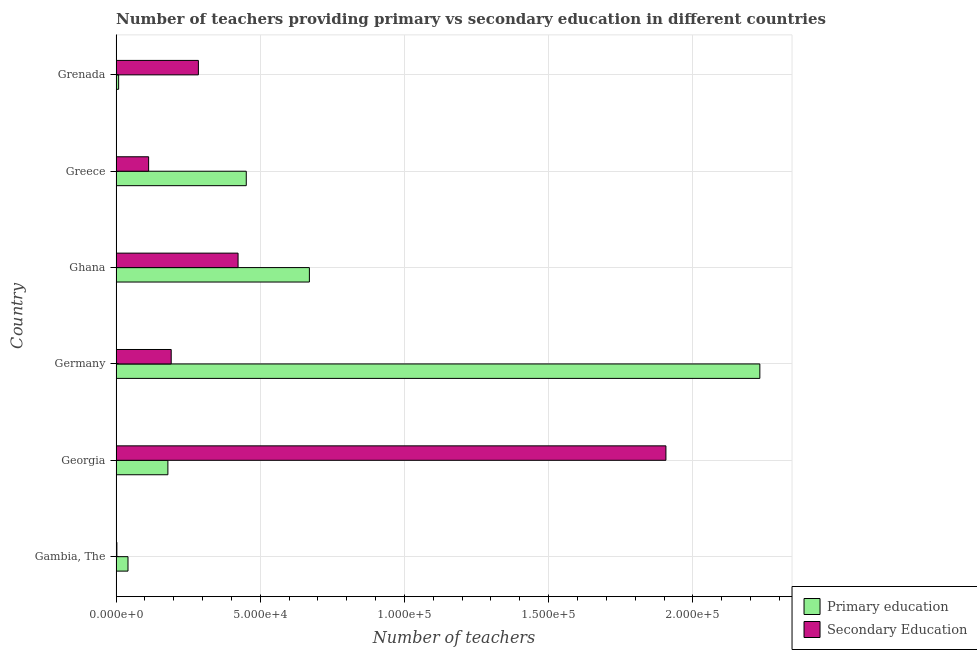How many groups of bars are there?
Your answer should be very brief. 6. Are the number of bars on each tick of the Y-axis equal?
Make the answer very short. Yes. How many bars are there on the 1st tick from the top?
Offer a terse response. 2. How many bars are there on the 5th tick from the bottom?
Keep it short and to the point. 2. What is the number of primary teachers in Greece?
Offer a terse response. 4.51e+04. Across all countries, what is the maximum number of secondary teachers?
Offer a very short reply. 1.91e+05. Across all countries, what is the minimum number of primary teachers?
Give a very brief answer. 869. In which country was the number of primary teachers minimum?
Keep it short and to the point. Grenada. What is the total number of secondary teachers in the graph?
Provide a succinct answer. 2.92e+05. What is the difference between the number of primary teachers in Georgia and that in Grenada?
Make the answer very short. 1.71e+04. What is the difference between the number of primary teachers in Ghana and the number of secondary teachers in Gambia, The?
Your answer should be very brief. 6.68e+04. What is the average number of primary teachers per country?
Ensure brevity in your answer.  5.97e+04. What is the difference between the number of primary teachers and number of secondary teachers in Germany?
Offer a very short reply. 2.04e+05. What is the ratio of the number of primary teachers in Ghana to that in Grenada?
Provide a short and direct response. 77.12. What is the difference between the highest and the second highest number of secondary teachers?
Offer a terse response. 1.48e+05. What is the difference between the highest and the lowest number of secondary teachers?
Your response must be concise. 1.90e+05. In how many countries, is the number of secondary teachers greater than the average number of secondary teachers taken over all countries?
Your answer should be compact. 1. What does the 1st bar from the top in Georgia represents?
Ensure brevity in your answer.  Secondary Education. What does the 2nd bar from the bottom in Grenada represents?
Your answer should be compact. Secondary Education. Are all the bars in the graph horizontal?
Your answer should be compact. Yes. What is the difference between two consecutive major ticks on the X-axis?
Provide a succinct answer. 5.00e+04. Are the values on the major ticks of X-axis written in scientific E-notation?
Keep it short and to the point. Yes. Does the graph contain grids?
Give a very brief answer. Yes. Where does the legend appear in the graph?
Your response must be concise. Bottom right. What is the title of the graph?
Offer a very short reply. Number of teachers providing primary vs secondary education in different countries. What is the label or title of the X-axis?
Keep it short and to the point. Number of teachers. What is the Number of teachers of Primary education in Gambia, The?
Ensure brevity in your answer.  4118. What is the Number of teachers in Secondary Education in Gambia, The?
Offer a terse response. 260. What is the Number of teachers of Primary education in Georgia?
Your answer should be very brief. 1.80e+04. What is the Number of teachers of Secondary Education in Georgia?
Ensure brevity in your answer.  1.91e+05. What is the Number of teachers of Primary education in Germany?
Your response must be concise. 2.23e+05. What is the Number of teachers in Secondary Education in Germany?
Your answer should be compact. 1.91e+04. What is the Number of teachers in Primary education in Ghana?
Your answer should be compact. 6.70e+04. What is the Number of teachers in Secondary Education in Ghana?
Your answer should be very brief. 4.23e+04. What is the Number of teachers in Primary education in Greece?
Your answer should be very brief. 4.51e+04. What is the Number of teachers in Secondary Education in Greece?
Offer a very short reply. 1.13e+04. What is the Number of teachers in Primary education in Grenada?
Provide a short and direct response. 869. What is the Number of teachers in Secondary Education in Grenada?
Offer a terse response. 2.85e+04. Across all countries, what is the maximum Number of teachers in Primary education?
Keep it short and to the point. 2.23e+05. Across all countries, what is the maximum Number of teachers of Secondary Education?
Your answer should be very brief. 1.91e+05. Across all countries, what is the minimum Number of teachers of Primary education?
Keep it short and to the point. 869. Across all countries, what is the minimum Number of teachers in Secondary Education?
Your response must be concise. 260. What is the total Number of teachers in Primary education in the graph?
Ensure brevity in your answer.  3.58e+05. What is the total Number of teachers in Secondary Education in the graph?
Provide a short and direct response. 2.92e+05. What is the difference between the Number of teachers of Primary education in Gambia, The and that in Georgia?
Your response must be concise. -1.38e+04. What is the difference between the Number of teachers of Secondary Education in Gambia, The and that in Georgia?
Offer a terse response. -1.90e+05. What is the difference between the Number of teachers in Primary education in Gambia, The and that in Germany?
Offer a very short reply. -2.19e+05. What is the difference between the Number of teachers in Secondary Education in Gambia, The and that in Germany?
Provide a succinct answer. -1.88e+04. What is the difference between the Number of teachers of Primary education in Gambia, The and that in Ghana?
Keep it short and to the point. -6.29e+04. What is the difference between the Number of teachers in Secondary Education in Gambia, The and that in Ghana?
Offer a terse response. -4.20e+04. What is the difference between the Number of teachers of Primary education in Gambia, The and that in Greece?
Provide a short and direct response. -4.10e+04. What is the difference between the Number of teachers of Secondary Education in Gambia, The and that in Greece?
Your response must be concise. -1.10e+04. What is the difference between the Number of teachers in Primary education in Gambia, The and that in Grenada?
Your response must be concise. 3249. What is the difference between the Number of teachers of Secondary Education in Gambia, The and that in Grenada?
Offer a terse response. -2.83e+04. What is the difference between the Number of teachers of Primary education in Georgia and that in Germany?
Provide a short and direct response. -2.05e+05. What is the difference between the Number of teachers in Secondary Education in Georgia and that in Germany?
Offer a very short reply. 1.72e+05. What is the difference between the Number of teachers in Primary education in Georgia and that in Ghana?
Provide a short and direct response. -4.91e+04. What is the difference between the Number of teachers of Secondary Education in Georgia and that in Ghana?
Offer a terse response. 1.48e+05. What is the difference between the Number of teachers in Primary education in Georgia and that in Greece?
Ensure brevity in your answer.  -2.72e+04. What is the difference between the Number of teachers of Secondary Education in Georgia and that in Greece?
Provide a succinct answer. 1.79e+05. What is the difference between the Number of teachers of Primary education in Georgia and that in Grenada?
Offer a very short reply. 1.71e+04. What is the difference between the Number of teachers in Secondary Education in Georgia and that in Grenada?
Provide a short and direct response. 1.62e+05. What is the difference between the Number of teachers in Primary education in Germany and that in Ghana?
Make the answer very short. 1.56e+05. What is the difference between the Number of teachers of Secondary Education in Germany and that in Ghana?
Your response must be concise. -2.32e+04. What is the difference between the Number of teachers of Primary education in Germany and that in Greece?
Provide a short and direct response. 1.78e+05. What is the difference between the Number of teachers of Secondary Education in Germany and that in Greece?
Offer a terse response. 7828. What is the difference between the Number of teachers of Primary education in Germany and that in Grenada?
Ensure brevity in your answer.  2.22e+05. What is the difference between the Number of teachers of Secondary Education in Germany and that in Grenada?
Give a very brief answer. -9433. What is the difference between the Number of teachers in Primary education in Ghana and that in Greece?
Your answer should be compact. 2.19e+04. What is the difference between the Number of teachers of Secondary Education in Ghana and that in Greece?
Make the answer very short. 3.10e+04. What is the difference between the Number of teachers of Primary education in Ghana and that in Grenada?
Provide a short and direct response. 6.62e+04. What is the difference between the Number of teachers of Secondary Education in Ghana and that in Grenada?
Offer a very short reply. 1.38e+04. What is the difference between the Number of teachers in Primary education in Greece and that in Grenada?
Offer a very short reply. 4.43e+04. What is the difference between the Number of teachers in Secondary Education in Greece and that in Grenada?
Give a very brief answer. -1.73e+04. What is the difference between the Number of teachers in Primary education in Gambia, The and the Number of teachers in Secondary Education in Georgia?
Your answer should be very brief. -1.87e+05. What is the difference between the Number of teachers of Primary education in Gambia, The and the Number of teachers of Secondary Education in Germany?
Make the answer very short. -1.50e+04. What is the difference between the Number of teachers in Primary education in Gambia, The and the Number of teachers in Secondary Education in Ghana?
Give a very brief answer. -3.82e+04. What is the difference between the Number of teachers of Primary education in Gambia, The and the Number of teachers of Secondary Education in Greece?
Offer a very short reply. -7151. What is the difference between the Number of teachers in Primary education in Gambia, The and the Number of teachers in Secondary Education in Grenada?
Provide a short and direct response. -2.44e+04. What is the difference between the Number of teachers in Primary education in Georgia and the Number of teachers in Secondary Education in Germany?
Provide a succinct answer. -1147. What is the difference between the Number of teachers of Primary education in Georgia and the Number of teachers of Secondary Education in Ghana?
Offer a terse response. -2.43e+04. What is the difference between the Number of teachers in Primary education in Georgia and the Number of teachers in Secondary Education in Greece?
Make the answer very short. 6681. What is the difference between the Number of teachers in Primary education in Georgia and the Number of teachers in Secondary Education in Grenada?
Ensure brevity in your answer.  -1.06e+04. What is the difference between the Number of teachers of Primary education in Germany and the Number of teachers of Secondary Education in Ghana?
Provide a short and direct response. 1.81e+05. What is the difference between the Number of teachers of Primary education in Germany and the Number of teachers of Secondary Education in Greece?
Your response must be concise. 2.12e+05. What is the difference between the Number of teachers in Primary education in Germany and the Number of teachers in Secondary Education in Grenada?
Your answer should be very brief. 1.95e+05. What is the difference between the Number of teachers of Primary education in Ghana and the Number of teachers of Secondary Education in Greece?
Ensure brevity in your answer.  5.58e+04. What is the difference between the Number of teachers in Primary education in Ghana and the Number of teachers in Secondary Education in Grenada?
Give a very brief answer. 3.85e+04. What is the difference between the Number of teachers of Primary education in Greece and the Number of teachers of Secondary Education in Grenada?
Give a very brief answer. 1.66e+04. What is the average Number of teachers in Primary education per country?
Your answer should be very brief. 5.97e+04. What is the average Number of teachers of Secondary Education per country?
Provide a short and direct response. 4.87e+04. What is the difference between the Number of teachers of Primary education and Number of teachers of Secondary Education in Gambia, The?
Your answer should be compact. 3858. What is the difference between the Number of teachers of Primary education and Number of teachers of Secondary Education in Georgia?
Make the answer very short. -1.73e+05. What is the difference between the Number of teachers of Primary education and Number of teachers of Secondary Education in Germany?
Keep it short and to the point. 2.04e+05. What is the difference between the Number of teachers of Primary education and Number of teachers of Secondary Education in Ghana?
Your response must be concise. 2.47e+04. What is the difference between the Number of teachers in Primary education and Number of teachers in Secondary Education in Greece?
Offer a terse response. 3.39e+04. What is the difference between the Number of teachers of Primary education and Number of teachers of Secondary Education in Grenada?
Your answer should be compact. -2.77e+04. What is the ratio of the Number of teachers of Primary education in Gambia, The to that in Georgia?
Your answer should be very brief. 0.23. What is the ratio of the Number of teachers of Secondary Education in Gambia, The to that in Georgia?
Your answer should be very brief. 0. What is the ratio of the Number of teachers of Primary education in Gambia, The to that in Germany?
Offer a very short reply. 0.02. What is the ratio of the Number of teachers in Secondary Education in Gambia, The to that in Germany?
Your answer should be compact. 0.01. What is the ratio of the Number of teachers in Primary education in Gambia, The to that in Ghana?
Provide a short and direct response. 0.06. What is the ratio of the Number of teachers of Secondary Education in Gambia, The to that in Ghana?
Provide a short and direct response. 0.01. What is the ratio of the Number of teachers of Primary education in Gambia, The to that in Greece?
Keep it short and to the point. 0.09. What is the ratio of the Number of teachers in Secondary Education in Gambia, The to that in Greece?
Provide a short and direct response. 0.02. What is the ratio of the Number of teachers of Primary education in Gambia, The to that in Grenada?
Your answer should be very brief. 4.74. What is the ratio of the Number of teachers in Secondary Education in Gambia, The to that in Grenada?
Offer a very short reply. 0.01. What is the ratio of the Number of teachers in Primary education in Georgia to that in Germany?
Your answer should be very brief. 0.08. What is the ratio of the Number of teachers of Secondary Education in Georgia to that in Germany?
Keep it short and to the point. 9.98. What is the ratio of the Number of teachers in Primary education in Georgia to that in Ghana?
Keep it short and to the point. 0.27. What is the ratio of the Number of teachers in Secondary Education in Georgia to that in Ghana?
Offer a terse response. 4.51. What is the ratio of the Number of teachers in Primary education in Georgia to that in Greece?
Give a very brief answer. 0.4. What is the ratio of the Number of teachers of Secondary Education in Georgia to that in Greece?
Offer a very short reply. 16.92. What is the ratio of the Number of teachers of Primary education in Georgia to that in Grenada?
Give a very brief answer. 20.66. What is the ratio of the Number of teachers of Secondary Education in Georgia to that in Grenada?
Make the answer very short. 6.68. What is the ratio of the Number of teachers in Primary education in Germany to that in Ghana?
Your answer should be compact. 3.33. What is the ratio of the Number of teachers in Secondary Education in Germany to that in Ghana?
Your response must be concise. 0.45. What is the ratio of the Number of teachers of Primary education in Germany to that in Greece?
Your answer should be very brief. 4.95. What is the ratio of the Number of teachers in Secondary Education in Germany to that in Greece?
Provide a short and direct response. 1.69. What is the ratio of the Number of teachers of Primary education in Germany to that in Grenada?
Ensure brevity in your answer.  256.89. What is the ratio of the Number of teachers of Secondary Education in Germany to that in Grenada?
Make the answer very short. 0.67. What is the ratio of the Number of teachers in Primary education in Ghana to that in Greece?
Ensure brevity in your answer.  1.49. What is the ratio of the Number of teachers of Secondary Education in Ghana to that in Greece?
Your answer should be very brief. 3.75. What is the ratio of the Number of teachers in Primary education in Ghana to that in Grenada?
Offer a terse response. 77.12. What is the ratio of the Number of teachers of Secondary Education in Ghana to that in Grenada?
Offer a very short reply. 1.48. What is the ratio of the Number of teachers of Primary education in Greece to that in Grenada?
Provide a short and direct response. 51.93. What is the ratio of the Number of teachers of Secondary Education in Greece to that in Grenada?
Provide a short and direct response. 0.4. What is the difference between the highest and the second highest Number of teachers of Primary education?
Your answer should be compact. 1.56e+05. What is the difference between the highest and the second highest Number of teachers in Secondary Education?
Provide a short and direct response. 1.48e+05. What is the difference between the highest and the lowest Number of teachers of Primary education?
Keep it short and to the point. 2.22e+05. What is the difference between the highest and the lowest Number of teachers of Secondary Education?
Offer a very short reply. 1.90e+05. 